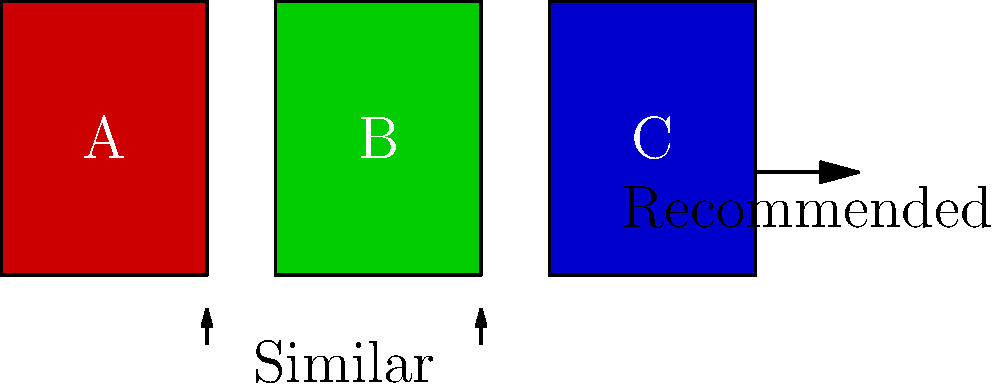In a movie recommendation system based on DVD cover art comparisons, if movies A and B are determined to be similar, and movie C is recommended based on this similarity, which machine learning technique is likely being used? To answer this question, let's break down the scenario and consider the machine learning techniques that could be applied:

1. Cover art comparison: The system is using visual information from DVD covers to determine similarity between movies. This suggests image processing is involved.

2. Similarity detection: Movies A and B are determined to be similar based on their cover art. This implies a similarity metric or distance function is being used to compare visual features.

3. Recommendation: Movie C is recommended based on the similarity between A and B. This indicates a form of collaborative filtering or content-based filtering.

4. Visual feature extraction: To compare cover arts, the system likely extracts visual features from the images, such as color schemes, textures, or object recognition.

5. Learning from patterns: The system learns to recommend movies based on visual similarities, which suggests it's identifying patterns in the data.

Considering these factors, the most likely machine learning technique being used is a Content-Based Recommendation System with image processing. This technique:

- Uses feature extraction to analyze the content (in this case, visual features of DVD covers)
- Computes similarity between items based on these features
- Recommends items similar to those the user has shown interest in

While collaborative filtering is also used in recommendation systems, the emphasis on visual similarity in this scenario points more towards a content-based approach.
Answer: Content-Based Recommendation System with image processing 